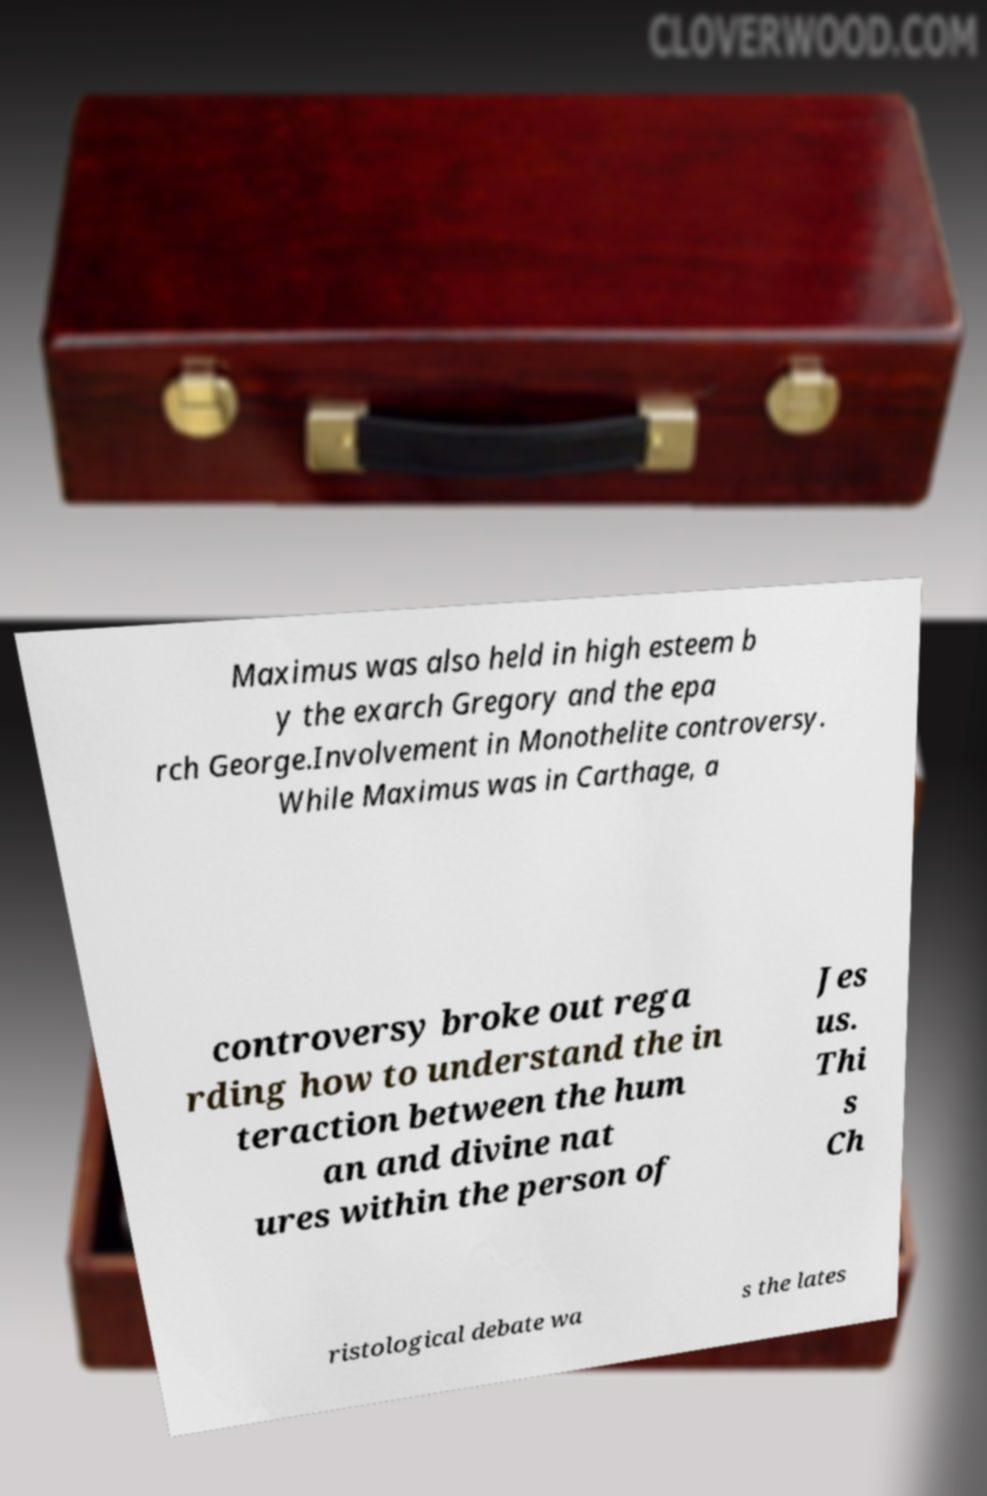Could you assist in decoding the text presented in this image and type it out clearly? Maximus was also held in high esteem b y the exarch Gregory and the epa rch George.Involvement in Monothelite controversy. While Maximus was in Carthage, a controversy broke out rega rding how to understand the in teraction between the hum an and divine nat ures within the person of Jes us. Thi s Ch ristological debate wa s the lates 